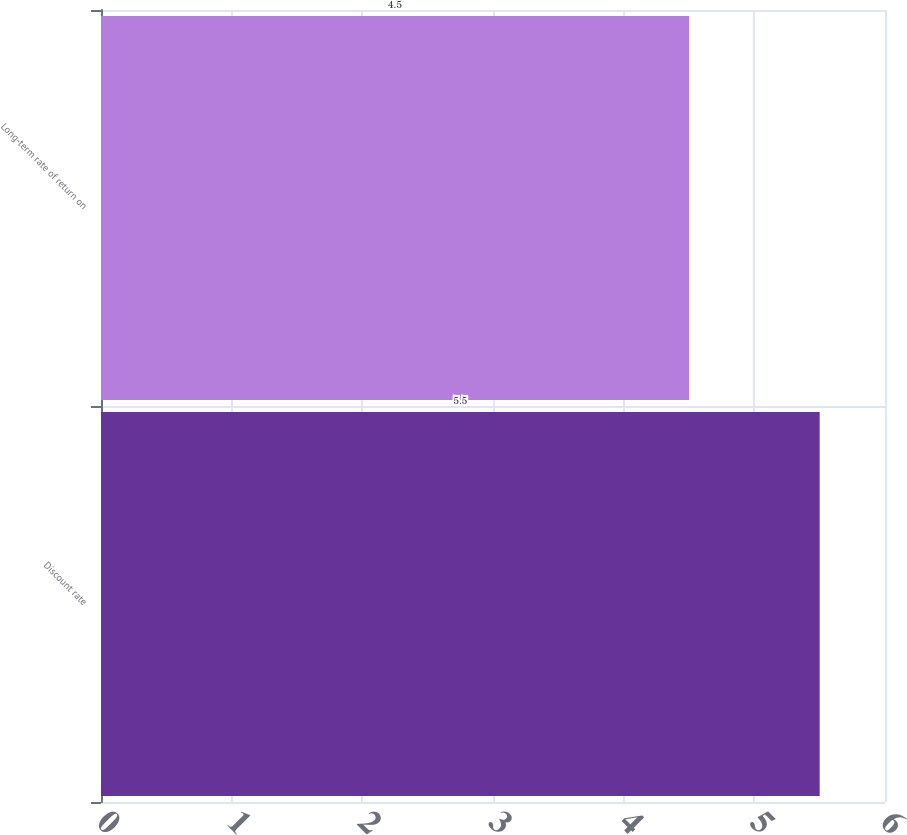Convert chart to OTSL. <chart><loc_0><loc_0><loc_500><loc_500><bar_chart><fcel>Discount rate<fcel>Long-term rate of return on<nl><fcel>5.5<fcel>4.5<nl></chart> 